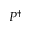<formula> <loc_0><loc_0><loc_500><loc_500>P ^ { \dagger }</formula> 